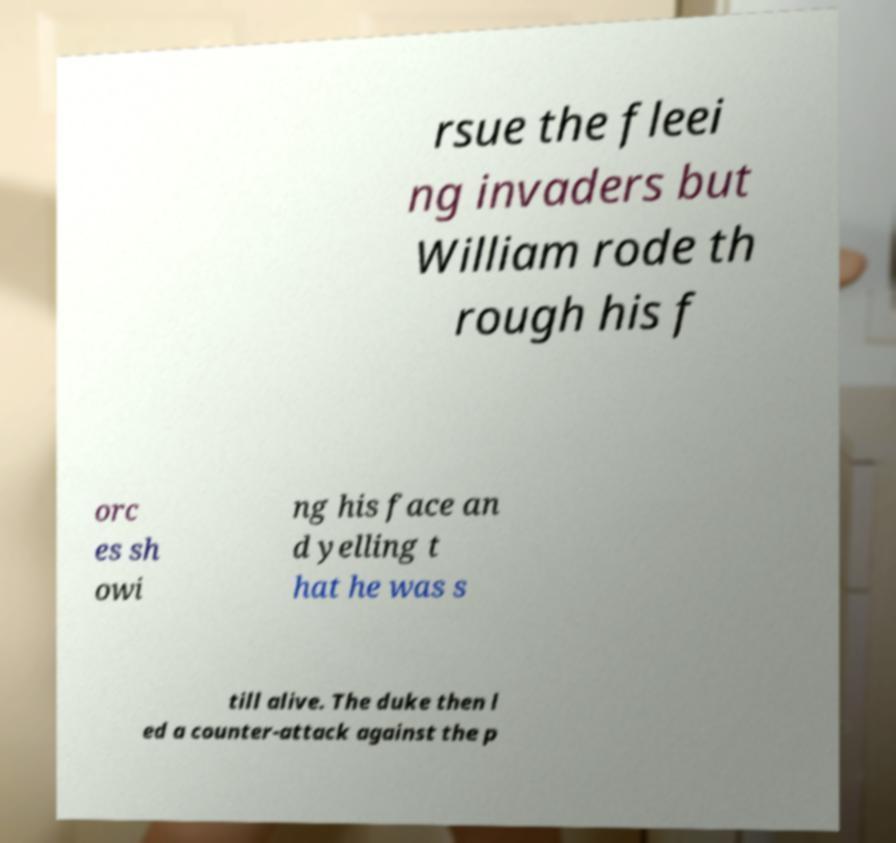For documentation purposes, I need the text within this image transcribed. Could you provide that? rsue the fleei ng invaders but William rode th rough his f orc es sh owi ng his face an d yelling t hat he was s till alive. The duke then l ed a counter-attack against the p 